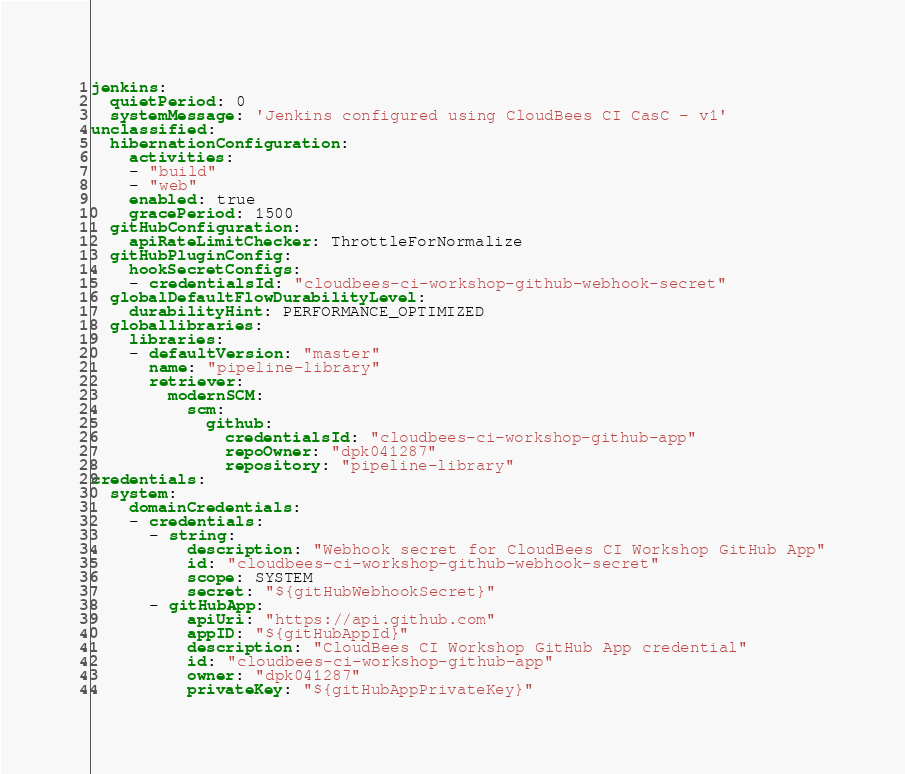<code> <loc_0><loc_0><loc_500><loc_500><_YAML_>jenkins:
  quietPeriod: 0
  systemMessage: 'Jenkins configured using CloudBees CI CasC - v1'
unclassified:
  hibernationConfiguration:
    activities:
    - "build"
    - "web"
    enabled: true
    gracePeriod: 1500
  gitHubConfiguration:
    apiRateLimitChecker: ThrottleForNormalize
  gitHubPluginConfig:
    hookSecretConfigs:
    - credentialsId: "cloudbees-ci-workshop-github-webhook-secret"
  globalDefaultFlowDurabilityLevel:
    durabilityHint: PERFORMANCE_OPTIMIZED
  globallibraries:
    libraries:
    - defaultVersion: "master"
      name: "pipeline-library"
      retriever:
        modernSCM:
          scm:
            github:
              credentialsId: "cloudbees-ci-workshop-github-app"
              repoOwner: "dpk041287"
              repository: "pipeline-library"
credentials:
  system:
    domainCredentials:
    - credentials:
      - string:
          description: "Webhook secret for CloudBees CI Workshop GitHub App"
          id: "cloudbees-ci-workshop-github-webhook-secret"
          scope: SYSTEM
          secret: "${gitHubWebhookSecret}"
      - gitHubApp:
          apiUri: "https://api.github.com"
          appID: "${gitHubAppId}"
          description: "CloudBees CI Workshop GitHub App credential"
          id: "cloudbees-ci-workshop-github-app"
          owner: "dpk041287"
          privateKey: "${gitHubAppPrivateKey}"
</code> 